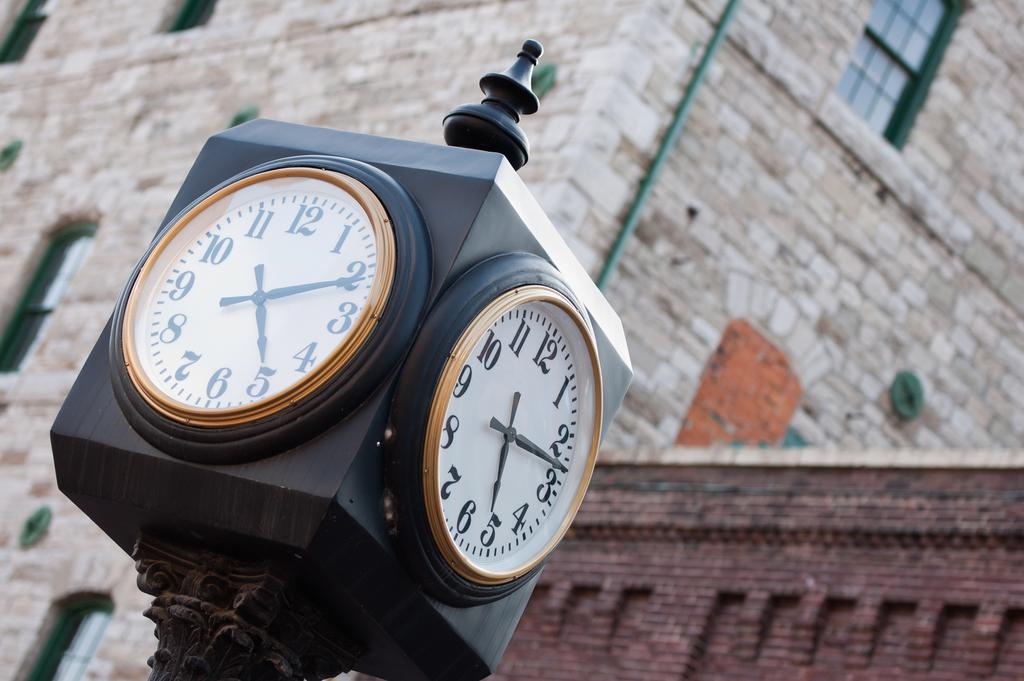<image>
Share a concise interpretation of the image provided. The clocks reads 5:11 on one side and 5:12 on the other side. 